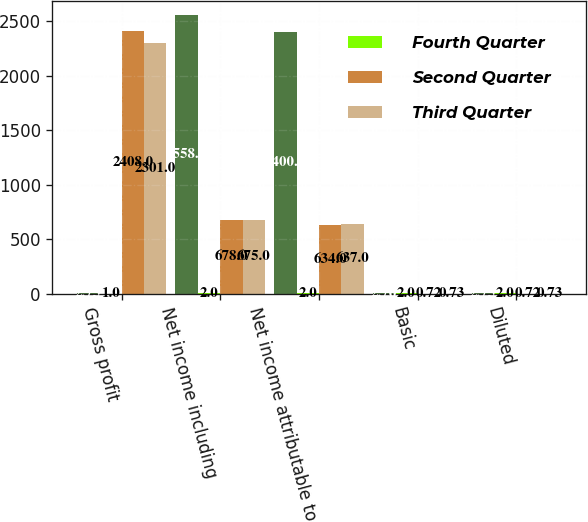Convert chart to OTSL. <chart><loc_0><loc_0><loc_500><loc_500><stacked_bar_chart><ecel><fcel>Gross profit<fcel>Net income including<fcel>Net income attributable to<fcel>Basic<fcel>Diluted<nl><fcel>nan<fcel>2.75<fcel>2558<fcel>2400<fcel>2.76<fcel>2.75<nl><fcel>Fourth Quarter<fcel>1<fcel>2<fcel>2<fcel>2<fcel>2<nl><fcel>Second Quarter<fcel>2408<fcel>678<fcel>634<fcel>0.72<fcel>0.72<nl><fcel>Third Quarter<fcel>2301<fcel>675<fcel>637<fcel>0.73<fcel>0.73<nl></chart> 